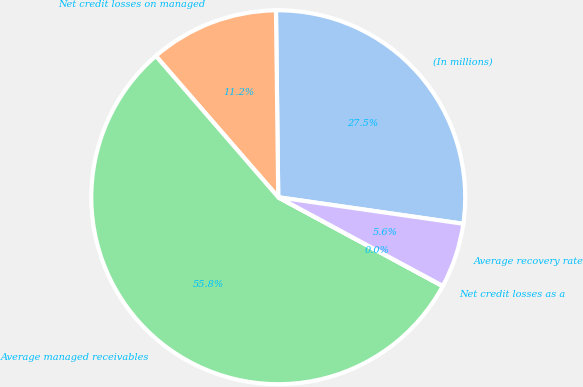<chart> <loc_0><loc_0><loc_500><loc_500><pie_chart><fcel>(In millions)<fcel>Net credit losses on managed<fcel>Average managed receivables<fcel>Net credit losses as a<fcel>Average recovery rate<nl><fcel>27.46%<fcel>11.17%<fcel>55.75%<fcel>0.02%<fcel>5.6%<nl></chart> 